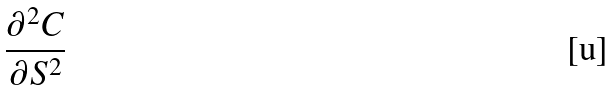Convert formula to latex. <formula><loc_0><loc_0><loc_500><loc_500>\frac { \partial ^ { 2 } C } { \partial S ^ { 2 } }</formula> 